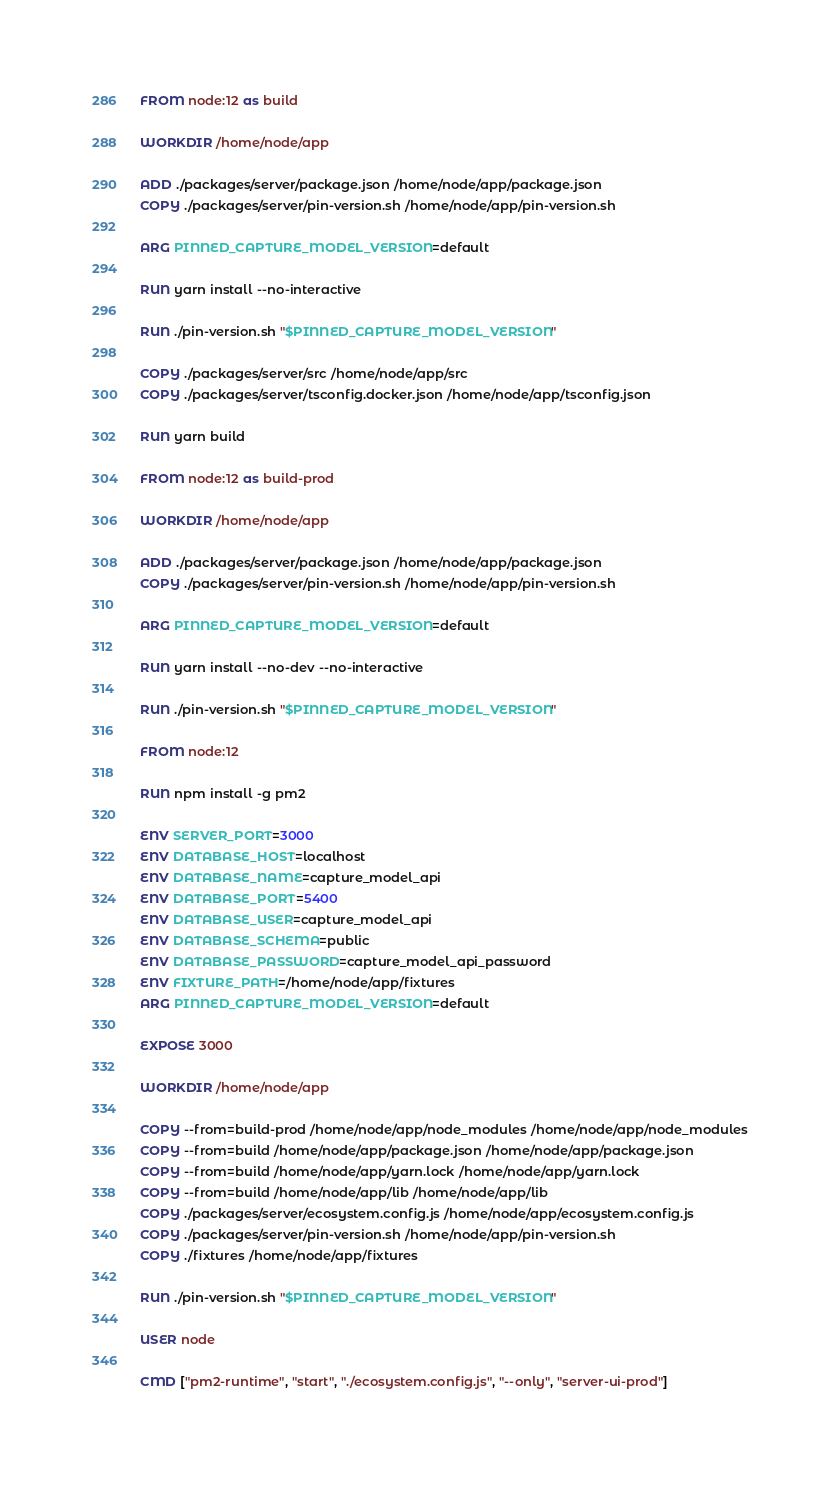<code> <loc_0><loc_0><loc_500><loc_500><_Dockerfile_>FROM node:12 as build

WORKDIR /home/node/app

ADD ./packages/server/package.json /home/node/app/package.json
COPY ./packages/server/pin-version.sh /home/node/app/pin-version.sh

ARG PINNED_CAPTURE_MODEL_VERSION=default

RUN yarn install --no-interactive

RUN ./pin-version.sh "$PINNED_CAPTURE_MODEL_VERSION"

COPY ./packages/server/src /home/node/app/src
COPY ./packages/server/tsconfig.docker.json /home/node/app/tsconfig.json

RUN yarn build

FROM node:12 as build-prod

WORKDIR /home/node/app

ADD ./packages/server/package.json /home/node/app/package.json
COPY ./packages/server/pin-version.sh /home/node/app/pin-version.sh

ARG PINNED_CAPTURE_MODEL_VERSION=default

RUN yarn install --no-dev --no-interactive

RUN ./pin-version.sh "$PINNED_CAPTURE_MODEL_VERSION"

FROM node:12

RUN npm install -g pm2

ENV SERVER_PORT=3000
ENV DATABASE_HOST=localhost
ENV DATABASE_NAME=capture_model_api
ENV DATABASE_PORT=5400
ENV DATABASE_USER=capture_model_api
ENV DATABASE_SCHEMA=public
ENV DATABASE_PASSWORD=capture_model_api_password
ENV FIXTURE_PATH=/home/node/app/fixtures
ARG PINNED_CAPTURE_MODEL_VERSION=default

EXPOSE 3000

WORKDIR /home/node/app

COPY --from=build-prod /home/node/app/node_modules /home/node/app/node_modules
COPY --from=build /home/node/app/package.json /home/node/app/package.json
COPY --from=build /home/node/app/yarn.lock /home/node/app/yarn.lock
COPY --from=build /home/node/app/lib /home/node/app/lib
COPY ./packages/server/ecosystem.config.js /home/node/app/ecosystem.config.js
COPY ./packages/server/pin-version.sh /home/node/app/pin-version.sh
COPY ./fixtures /home/node/app/fixtures

RUN ./pin-version.sh "$PINNED_CAPTURE_MODEL_VERSION"

USER node

CMD ["pm2-runtime", "start", "./ecosystem.config.js", "--only", "server-ui-prod"]
</code> 